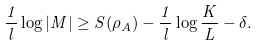Convert formula to latex. <formula><loc_0><loc_0><loc_500><loc_500>\frac { 1 } { l } \log | M | \geq S ( \rho _ { A } ) - \frac { 1 } { l } \log \frac { K } { L } - \delta .</formula> 